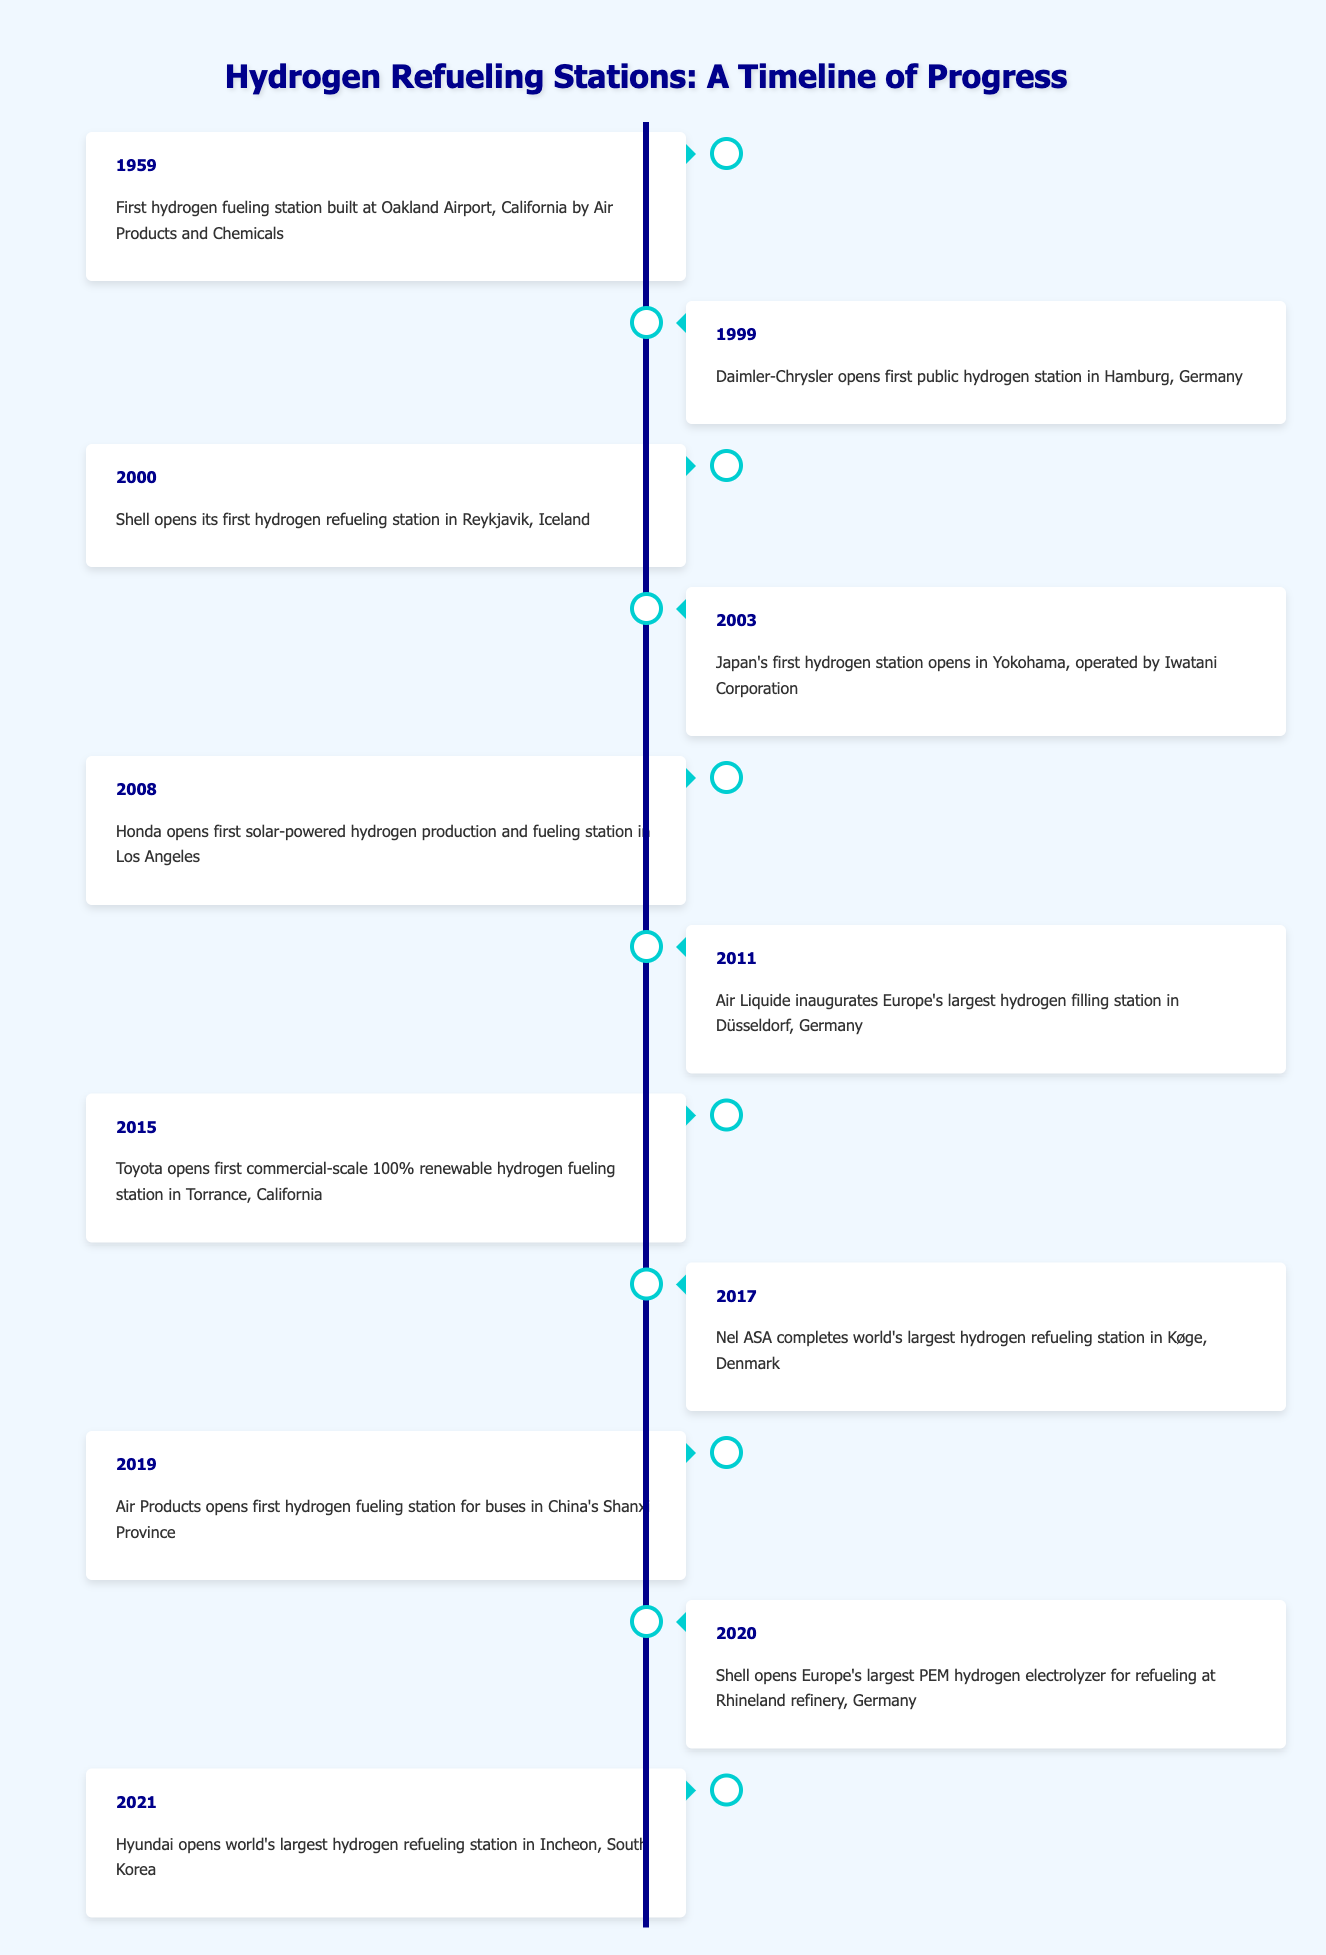What year was the first hydrogen fueling station built? The first hydrogen fueling station was built in 1959 at Oakland Airport, California by Air Products and Chemicals.
Answer: 1959 Which company opened the first public hydrogen station? The first public hydrogen station was opened by Daimler-Chrysler in 1999 in Hamburg, Germany.
Answer: Daimler-Chrysler How many hydrogen fueling stations were opened before 2010? The stations opened before 2010 are in 1959, 1999, 2000, 2003, and 2008, which totals to 5 stations.
Answer: 5 What is the year difference between the first and the last hydrogen fueling station mentioned? The first station was opened in 1959 and the last in 2021. The difference is 2021 - 1959 = 62 years.
Answer: 62 years Did any hydrogen stations open in 2011? Yes, Air Liquide inaugurated Europe's largest hydrogen filling station in Düsseldorf, Germany in 2011.
Answer: Yes Which country had the first solar-powered hydrogen production and fueling station? The first solar-powered hydrogen production and fueling station was opened by Honda in Los Angeles, California, so the country is the USA.
Answer: USA In which year was the largest hydrogen refueling station in the world completed? The world's largest hydrogen refueling station was completed in 2017 by Nel ASA in Køge, Denmark.
Answer: 2017 How many hydrogen stations have been opened in Germany according to the table? The stations in Germany are located in Hamburg (1999), Düsseldorf (2011), and Rhineland refinery (2020). Therefore, a total of 3 hydrogen stations has been opened in Germany.
Answer: 3 What percentage of the listed stations were opened after 2015? The stations opened after 2015 are in 2017, 2019, 2020, and 2021, totaling 4. Since there are 11 stations total, the percentage is (4/11) * 100 ≈ 36.36%.
Answer: Approximately 36.36% 